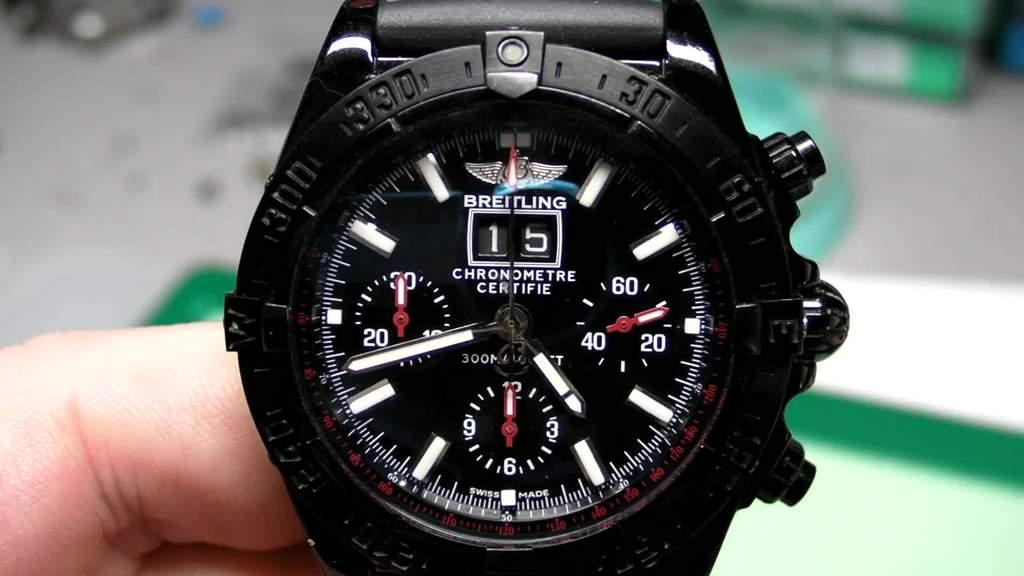<image>
Write a terse but informative summary of the picture. A black Breitling watch held in someone's hand. 